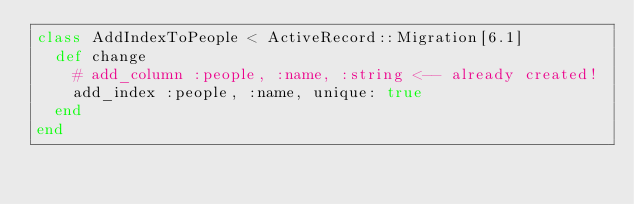<code> <loc_0><loc_0><loc_500><loc_500><_Ruby_>class AddIndexToPeople < ActiveRecord::Migration[6.1]
  def change
    # add_column :people, :name, :string <-- already created!
    add_index :people, :name, unique: true
  end
end
</code> 